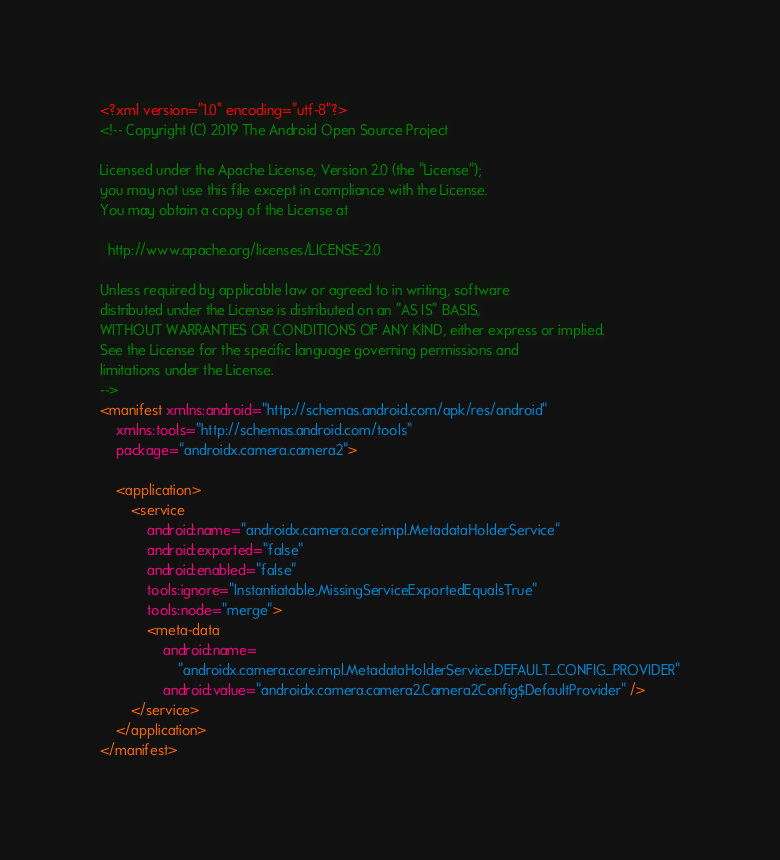Convert code to text. <code><loc_0><loc_0><loc_500><loc_500><_XML_><?xml version="1.0" encoding="utf-8"?>
<!-- Copyright (C) 2019 The Android Open Source Project

Licensed under the Apache License, Version 2.0 (the "License");
you may not use this file except in compliance with the License.
You may obtain a copy of the License at

  http://www.apache.org/licenses/LICENSE-2.0

Unless required by applicable law or agreed to in writing, software
distributed under the License is distributed on an "AS IS" BASIS,
WITHOUT WARRANTIES OR CONDITIONS OF ANY KIND, either express or implied.
See the License for the specific language governing permissions and
limitations under the License.
-->
<manifest xmlns:android="http://schemas.android.com/apk/res/android"
    xmlns:tools="http://schemas.android.com/tools"
    package="androidx.camera.camera2">

    <application>
        <service
            android:name="androidx.camera.core.impl.MetadataHolderService"
            android:exported="false"
            android:enabled="false"
            tools:ignore="Instantiatable,MissingServiceExportedEqualsTrue"
            tools:node="merge">
            <meta-data
                android:name=
                    "androidx.camera.core.impl.MetadataHolderService.DEFAULT_CONFIG_PROVIDER"
                android:value="androidx.camera.camera2.Camera2Config$DefaultProvider" />
        </service>
    </application>
</manifest>
</code> 